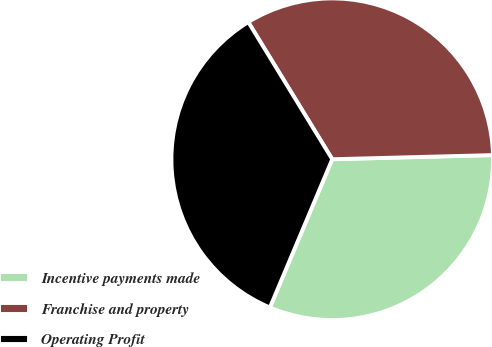<chart> <loc_0><loc_0><loc_500><loc_500><pie_chart><fcel>Incentive payments made<fcel>Franchise and property<fcel>Operating Profit<nl><fcel>31.75%<fcel>33.33%<fcel>34.92%<nl></chart> 